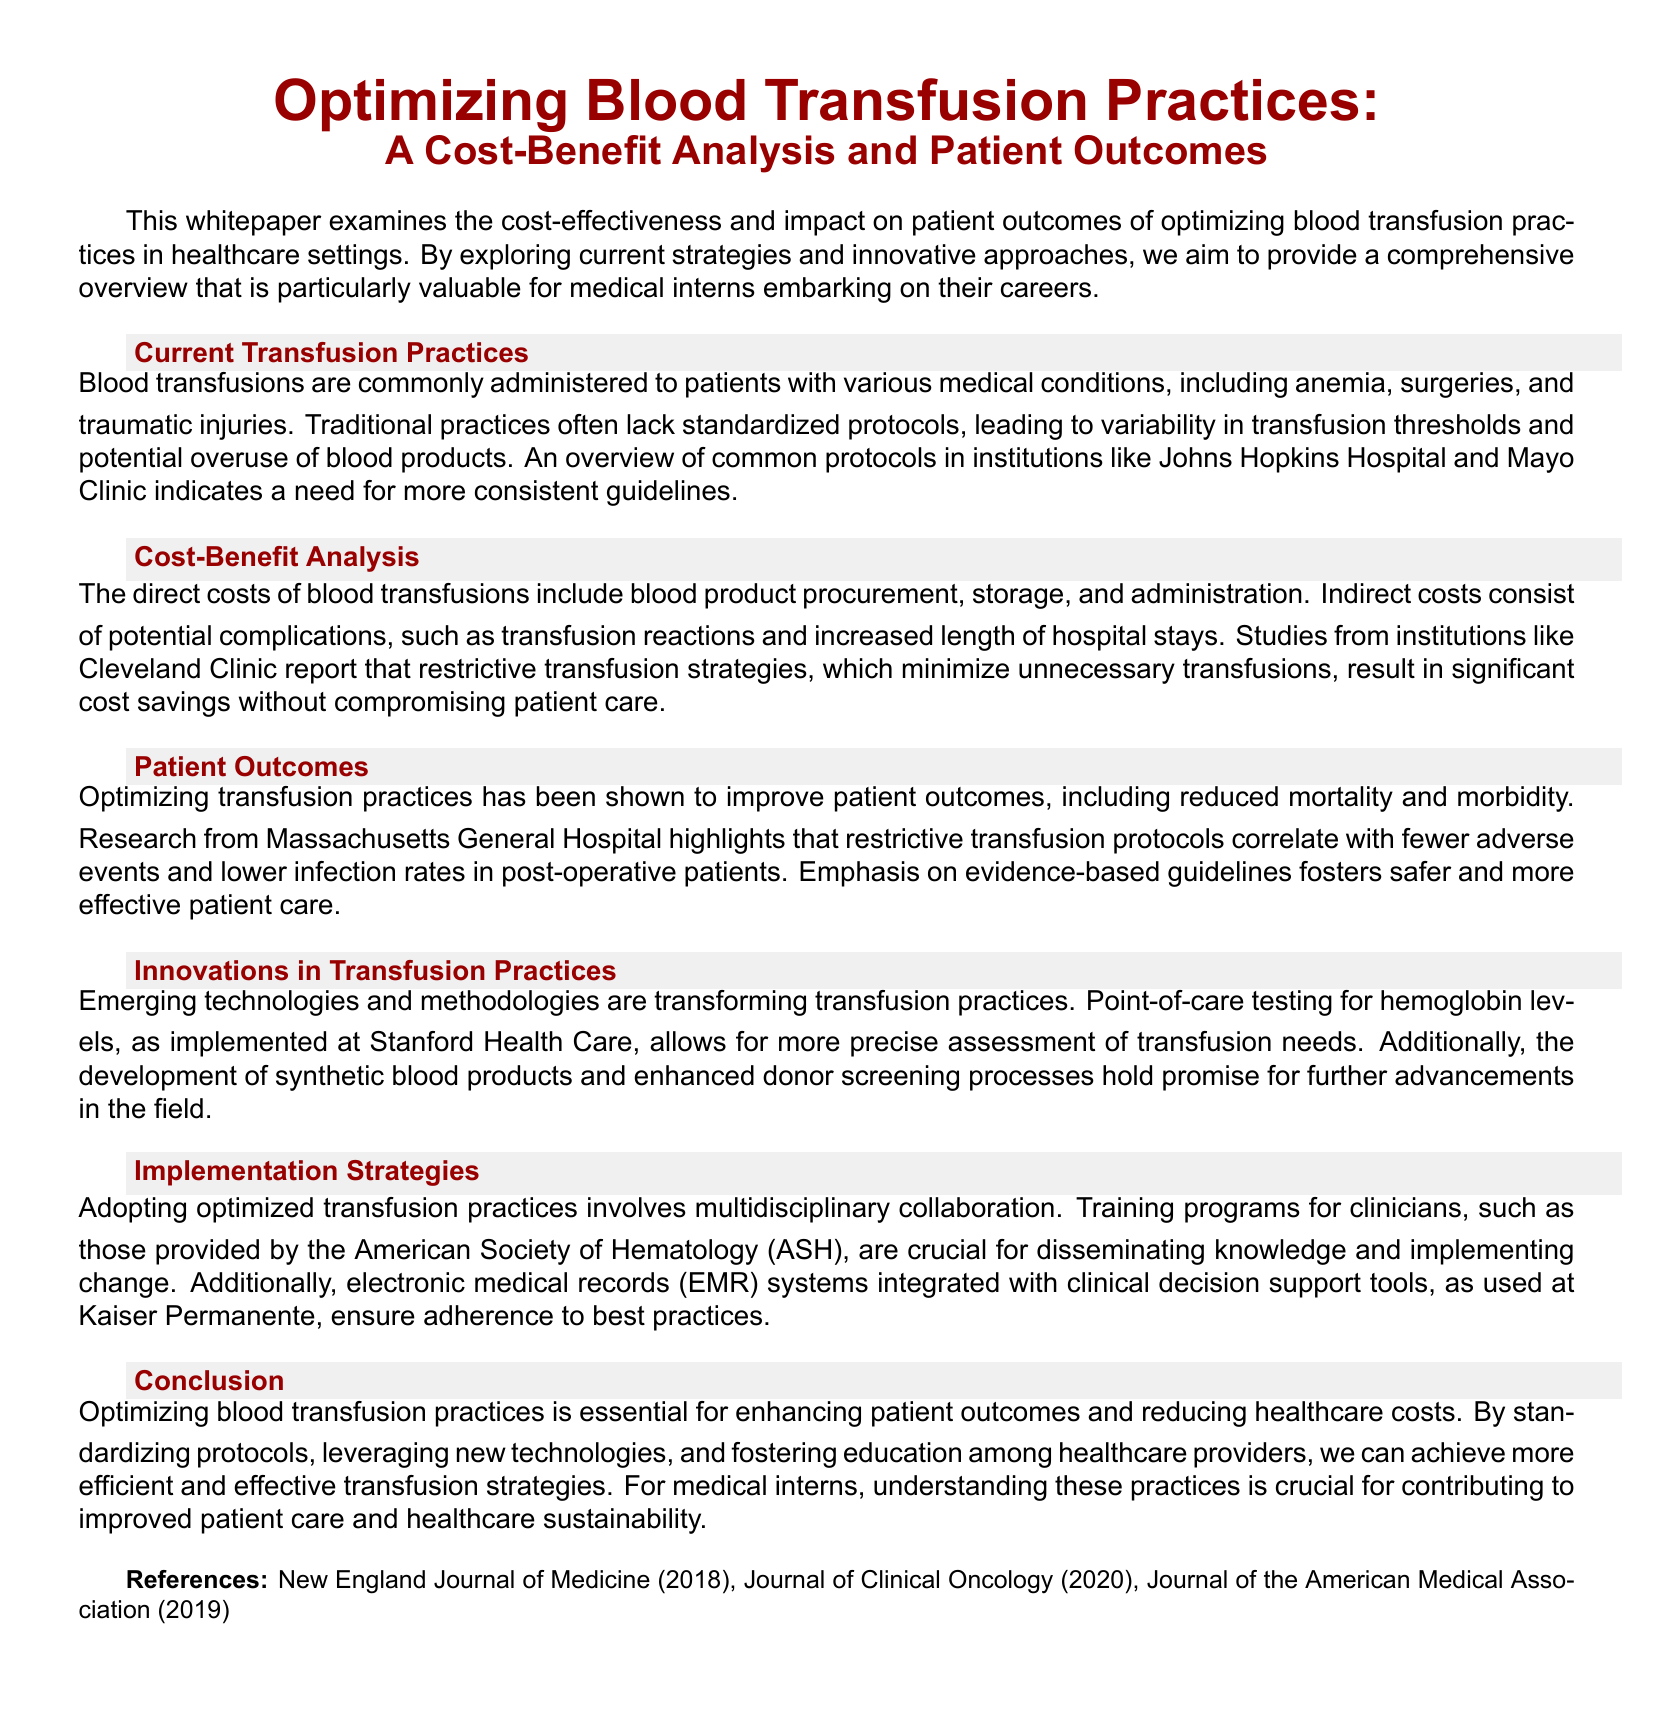What is the main focus of the whitepaper? The main focus is the cost-effectiveness and impact on patient outcomes of optimizing blood transfusion practices.
Answer: cost-effectiveness and patient outcomes Which institutions are mentioned as examples of current transfusion practices? The institutions mentioned include Johns Hopkins Hospital and Mayo Clinic.
Answer: Johns Hopkins Hospital and Mayo Clinic What type of transfusion strategy is associated with cost savings? Restrictive transfusion strategies minimize unnecessary transfusions and result in significant cost savings.
Answer: Restrictive transfusion strategies Which hospital's research correlates restrictive transfusion protocols with fewer adverse events? The research from Massachusetts General Hospital highlights this correlation.
Answer: Massachusetts General Hospital What is one of the emerging technologies mentioned that transforms transfusion practices? Point-of-care testing for hemoglobin levels is an emerging technology mentioned.
Answer: Point-of-care testing for hemoglobin levels Who provides crucial training programs for clinicians regarding optimized transfusion practices? The American Society of Hematology (ASH) provides these training programs.
Answer: American Society of Hematology (ASH) What are the potential benefits of adopting optimized transfusion practices? Optimizing practices leads to enhanced patient outcomes and reduced healthcare costs.
Answer: Enhanced patient outcomes and reduced healthcare costs What is emphasized for improving patient care in the conclusion? The emphasis is on standardizing protocols, leveraging new technologies, and fostering education among healthcare providers.
Answer: Standardizing protocols, leveraging new technologies, and fostering education among healthcare providers 